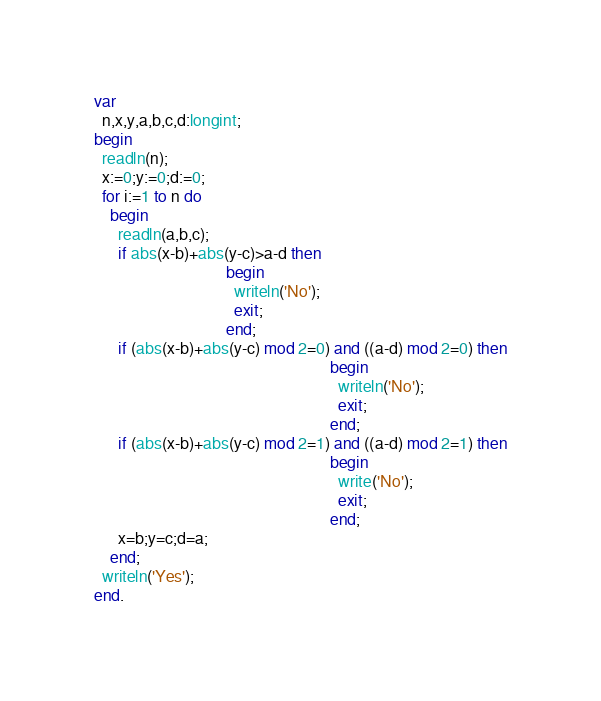<code> <loc_0><loc_0><loc_500><loc_500><_Pascal_>var
  n,x,y,a,b,c,d:longint;
begin
  readln(n);
  x:=0;y:=0;d:=0;
  for i:=1 to n do
    begin
      readln(a,b,c);
      if abs(x-b)+abs(y-c)>a-d then 
                                 begin
                                   writeln('No');
                                   exit;
                                 end;
      if (abs(x-b)+abs(y-c) mod 2=0) and ((a-d) mod 2=0) then
                                                           begin
                                                             writeln('No');
                                                             exit;
                                                           end;
      if (abs(x-b)+abs(y-c) mod 2=1) and ((a-d) mod 2=1) then
                                                           begin
                                                             write('No');
                                                             exit;
                                                           end;
      x=b;y=c;d=a;
    end;
  writeln('Yes');
end.</code> 